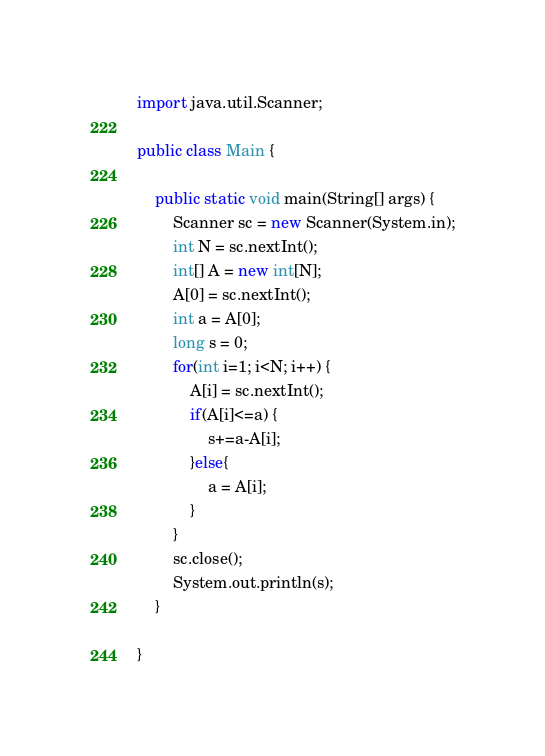<code> <loc_0><loc_0><loc_500><loc_500><_Java_>import java.util.Scanner;

public class Main {

	public static void main(String[] args) {
		Scanner sc = new Scanner(System.in);
		int N = sc.nextInt();
		int[] A = new int[N];
		A[0] = sc.nextInt();
		int a = A[0];
		long s = 0;
		for(int i=1; i<N; i++) {
			A[i] = sc.nextInt();
			if(A[i]<=a) {
				s+=a-A[i];
			}else{
				a = A[i];
			}
		}
		sc.close();
		System.out.println(s);
	}

}</code> 